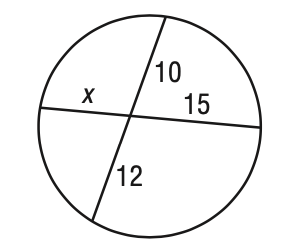Question: Solve for x in the figure.
Choices:
A. 8
B. 9
C. 10
D. 12
Answer with the letter. Answer: A 